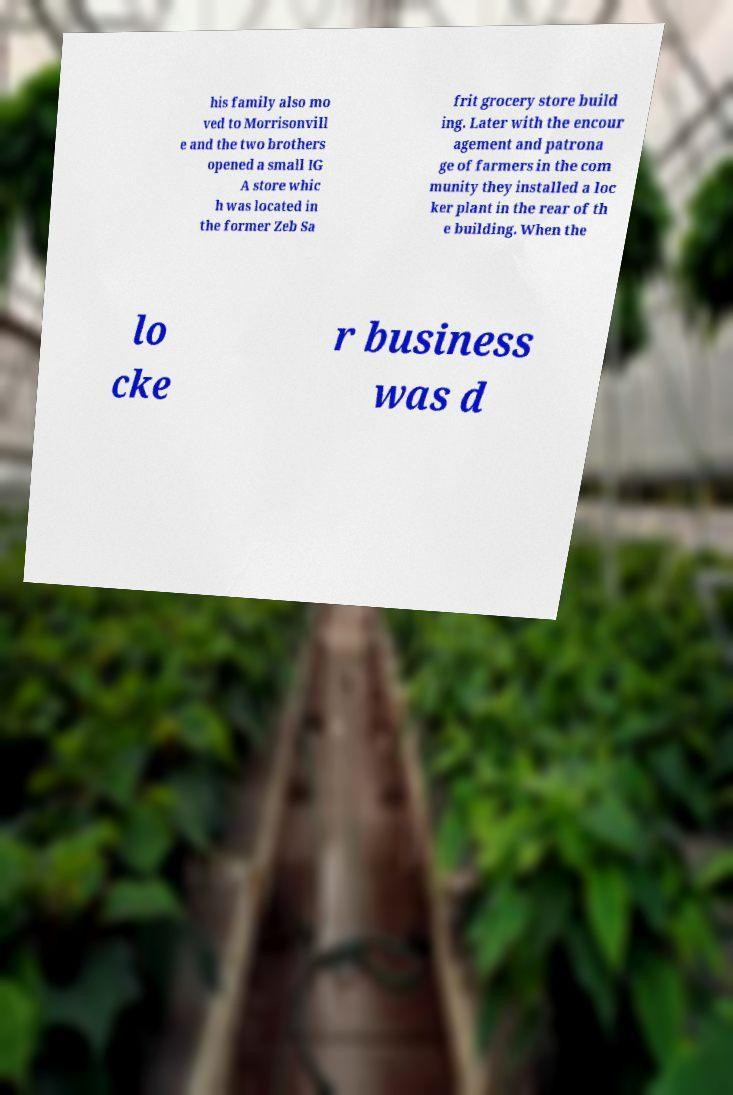There's text embedded in this image that I need extracted. Can you transcribe it verbatim? his family also mo ved to Morrisonvill e and the two brothers opened a small IG A store whic h was located in the former Zeb Sa frit grocery store build ing. Later with the encour agement and patrona ge of farmers in the com munity they installed a loc ker plant in the rear of th e building. When the lo cke r business was d 